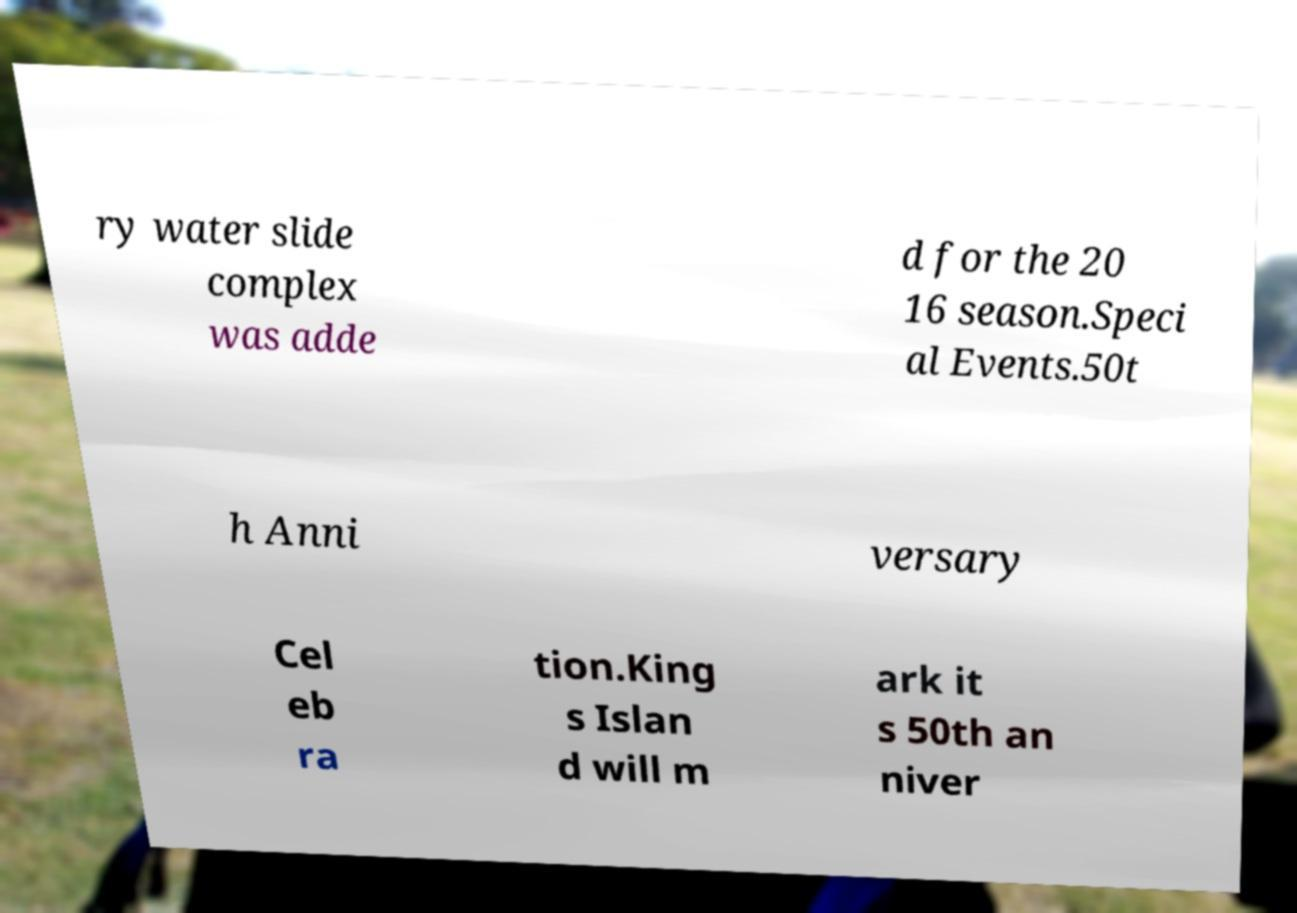Please identify and transcribe the text found in this image. ry water slide complex was adde d for the 20 16 season.Speci al Events.50t h Anni versary Cel eb ra tion.King s Islan d will m ark it s 50th an niver 